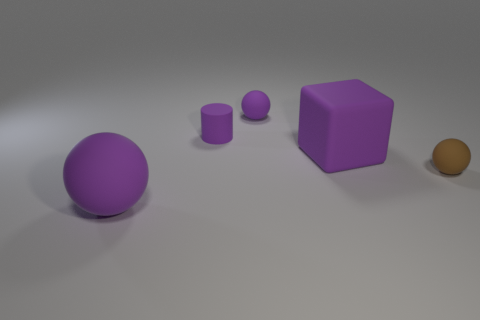There is a small object on the right side of the rubber cube; what color is it?
Provide a short and direct response. Brown. There is a purple sphere that is right of the large rubber sphere; does it have the same size as the brown rubber object behind the big purple matte ball?
Make the answer very short. Yes. Are there any rubber balls of the same size as the brown thing?
Ensure brevity in your answer.  Yes. There is a tiny rubber ball on the left side of the small brown rubber sphere; how many rubber cubes are behind it?
Provide a succinct answer. 0. What is the material of the big sphere?
Make the answer very short. Rubber. There is a big rubber sphere; what number of large purple balls are behind it?
Offer a terse response. 0. Do the large matte cube and the matte cylinder have the same color?
Your response must be concise. Yes. How many small balls have the same color as the large matte block?
Give a very brief answer. 1. Are there more purple matte objects than small purple cylinders?
Offer a terse response. Yes. There is a rubber sphere that is both left of the purple block and behind the large purple matte sphere; what size is it?
Keep it short and to the point. Small. 